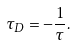<formula> <loc_0><loc_0><loc_500><loc_500>\tau _ { D } = - \frac { 1 } { \tau } .</formula> 